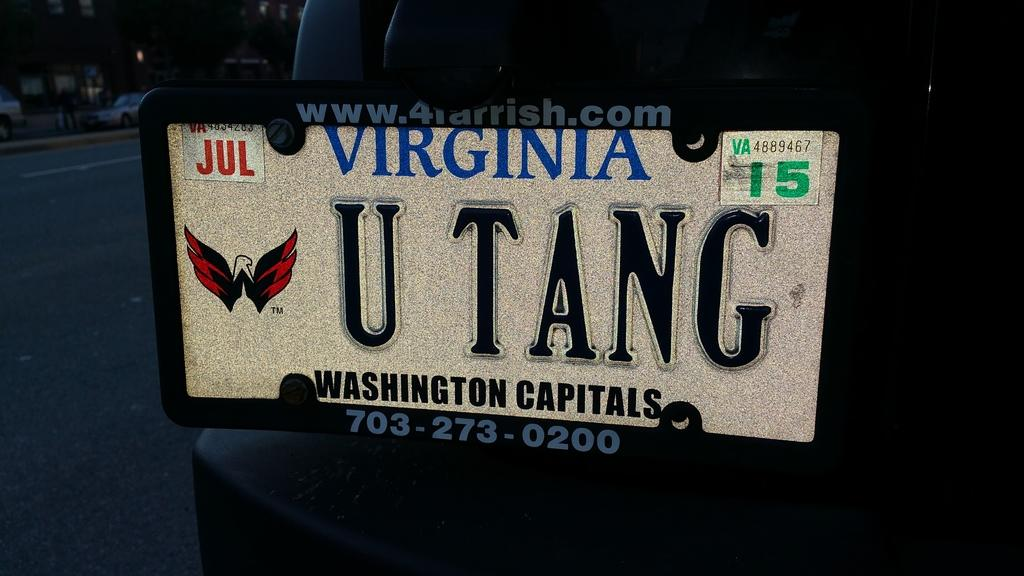<image>
Offer a succinct explanation of the picture presented. A car has a Virginia license plate that reads U TANG. 